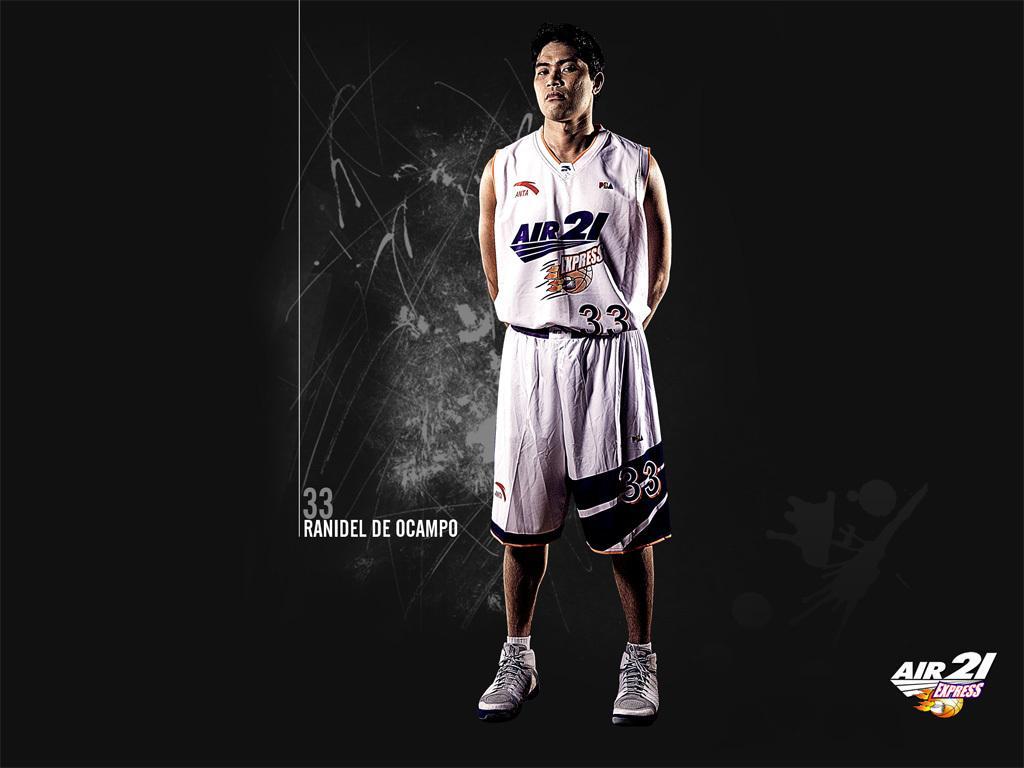In one or two sentences, can you explain what this image depicts? Background is dark. Here a person is standing. Here we can see watermarks in the image. 